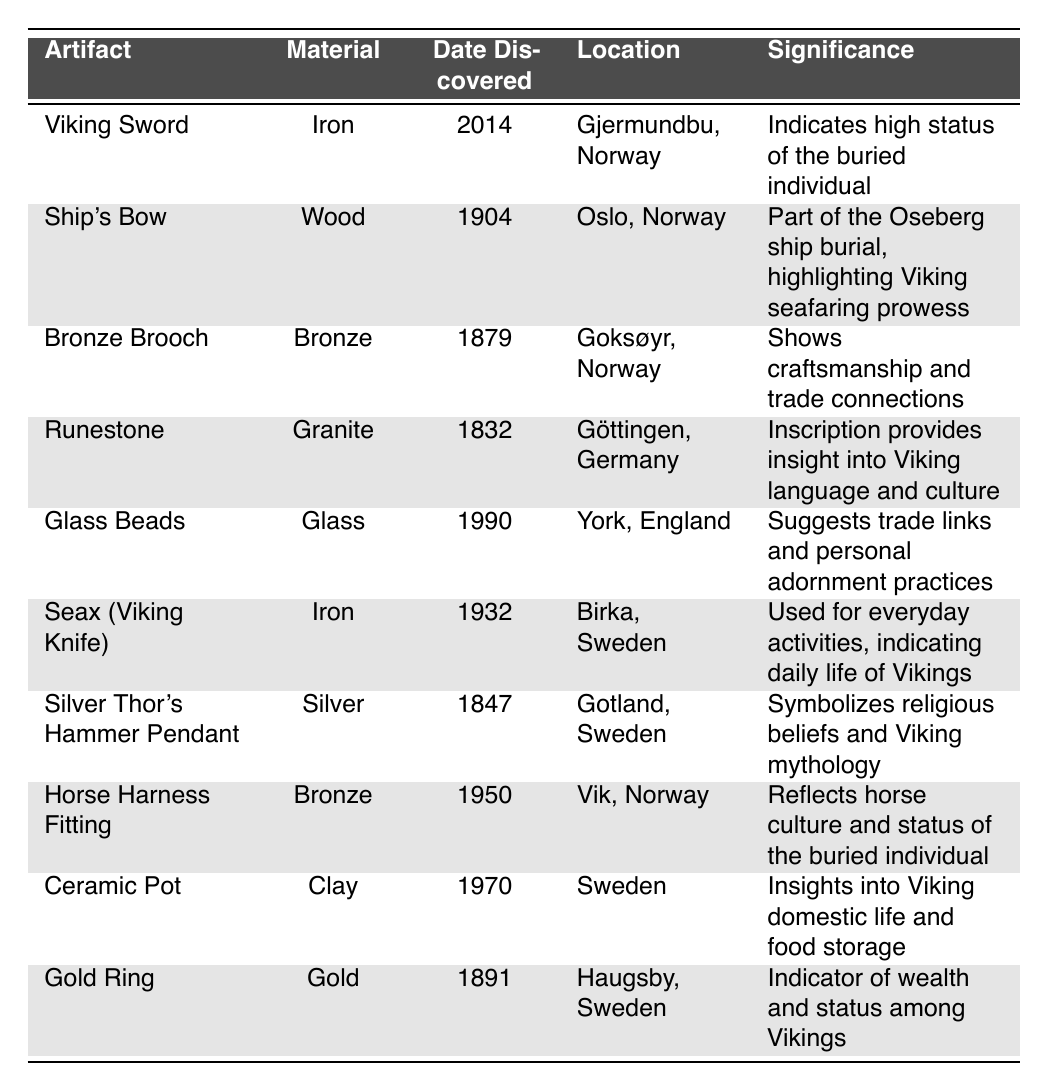What is the earliest year an artifact was discovered? The table lists several artifacts with their discovery years. The earliest year mentioned is 1832, linked to the Runestone discovered in Göttingen, Germany.
Answer: 1832 Which artifact was made of gold? The table indicates that the Gold Ring is the only artifact listed that is made of gold.
Answer: Gold Ring How many artifacts were discovered in Norway? There are five entries in the table that specify Norway as the location where the artifacts were found: the Viking Sword, Ship's Bow, Bronze Brooch, Horse Harness Fitting, and another item identified as part of the Oseberg ship burial.
Answer: 4 Is the Silver Thor's Hammer Pendant made of bronze? According to the table, the Silver Thor's Hammer Pendant is made of silver, not bronze.
Answer: No What significance does the Viking Sword have? The table states that the Viking Sword indicates the high status of the buried individual, highlighting the personal significance of this artifact in the burial context.
Answer: High status How many artifacts were created from materials that are not metals? Non-metal materials from the table include Wood (Ship's Bow), Glass (Glass Beads), and Clay (Ceramic Pot), totaling three artifacts made from non-metal materials.
Answer: 3 Which artifact discovered in 1990 suggests trade links? The Glass Beads were discovered in 1990 and are said to suggest trade links and personal adornment practices, indicating their importance in social exchanges.
Answer: Glass Beads What year saw the discovery of the artifact made from granite? The artifact made from granite is the Runestone, which was discovered in the year 1832 as stated in the table.
Answer: 1832 Which artifact was found in Germany, and what does its inscription provide? The Runestone was discovered in Göttingen, Germany, and its inscription provides insight into Viking language and culture, showcasing its cultural significance.
Answer: Runestone; insight into language and culture In which location was the Ceramic Pot discovered? The table states that the Ceramic Pot was discovered in Sweden, specifying its location clearly.
Answer: Sweden 